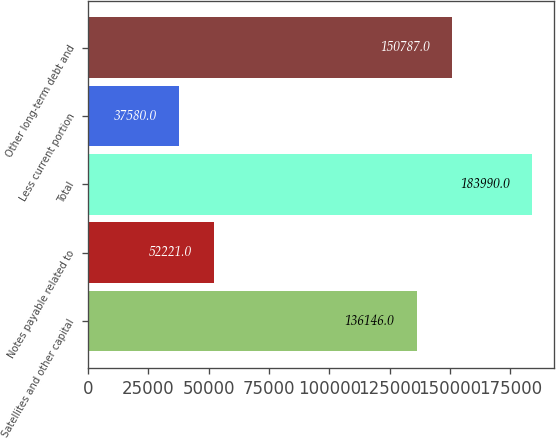Convert chart. <chart><loc_0><loc_0><loc_500><loc_500><bar_chart><fcel>Satellites and other capital<fcel>Notes payable related to<fcel>Total<fcel>Less current portion<fcel>Other long-term debt and<nl><fcel>136146<fcel>52221<fcel>183990<fcel>37580<fcel>150787<nl></chart> 